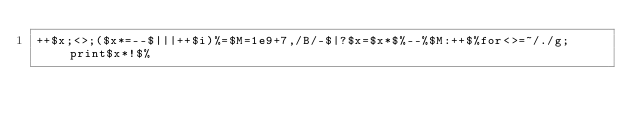Convert code to text. <code><loc_0><loc_0><loc_500><loc_500><_Perl_>++$x;<>;($x*=--$|||++$i)%=$M=1e9+7,/B/-$|?$x=$x*$%--%$M:++$%for<>=~/./g;print$x*!$%</code> 